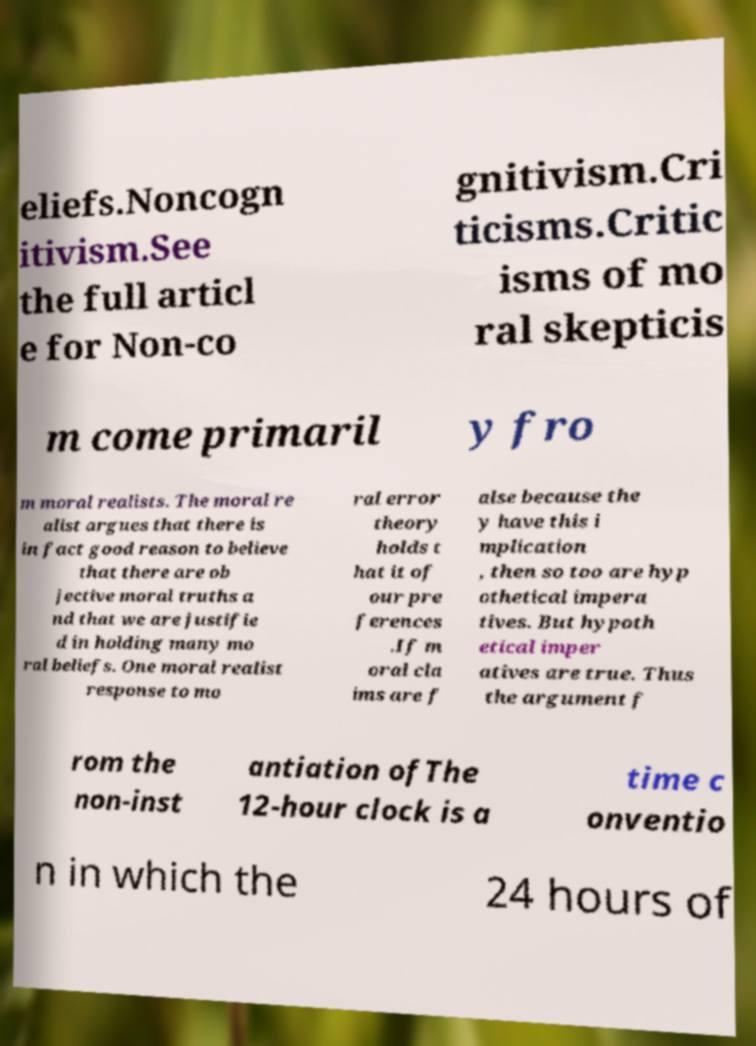There's text embedded in this image that I need extracted. Can you transcribe it verbatim? eliefs.Noncogn itivism.See the full articl e for Non-co gnitivism.Cri ticisms.Critic isms of mo ral skepticis m come primaril y fro m moral realists. The moral re alist argues that there is in fact good reason to believe that there are ob jective moral truths a nd that we are justifie d in holding many mo ral beliefs. One moral realist response to mo ral error theory holds t hat it of our pre ferences .If m oral cla ims are f alse because the y have this i mplication , then so too are hyp othetical impera tives. But hypoth etical imper atives are true. Thus the argument f rom the non-inst antiation ofThe 12-hour clock is a time c onventio n in which the 24 hours of 